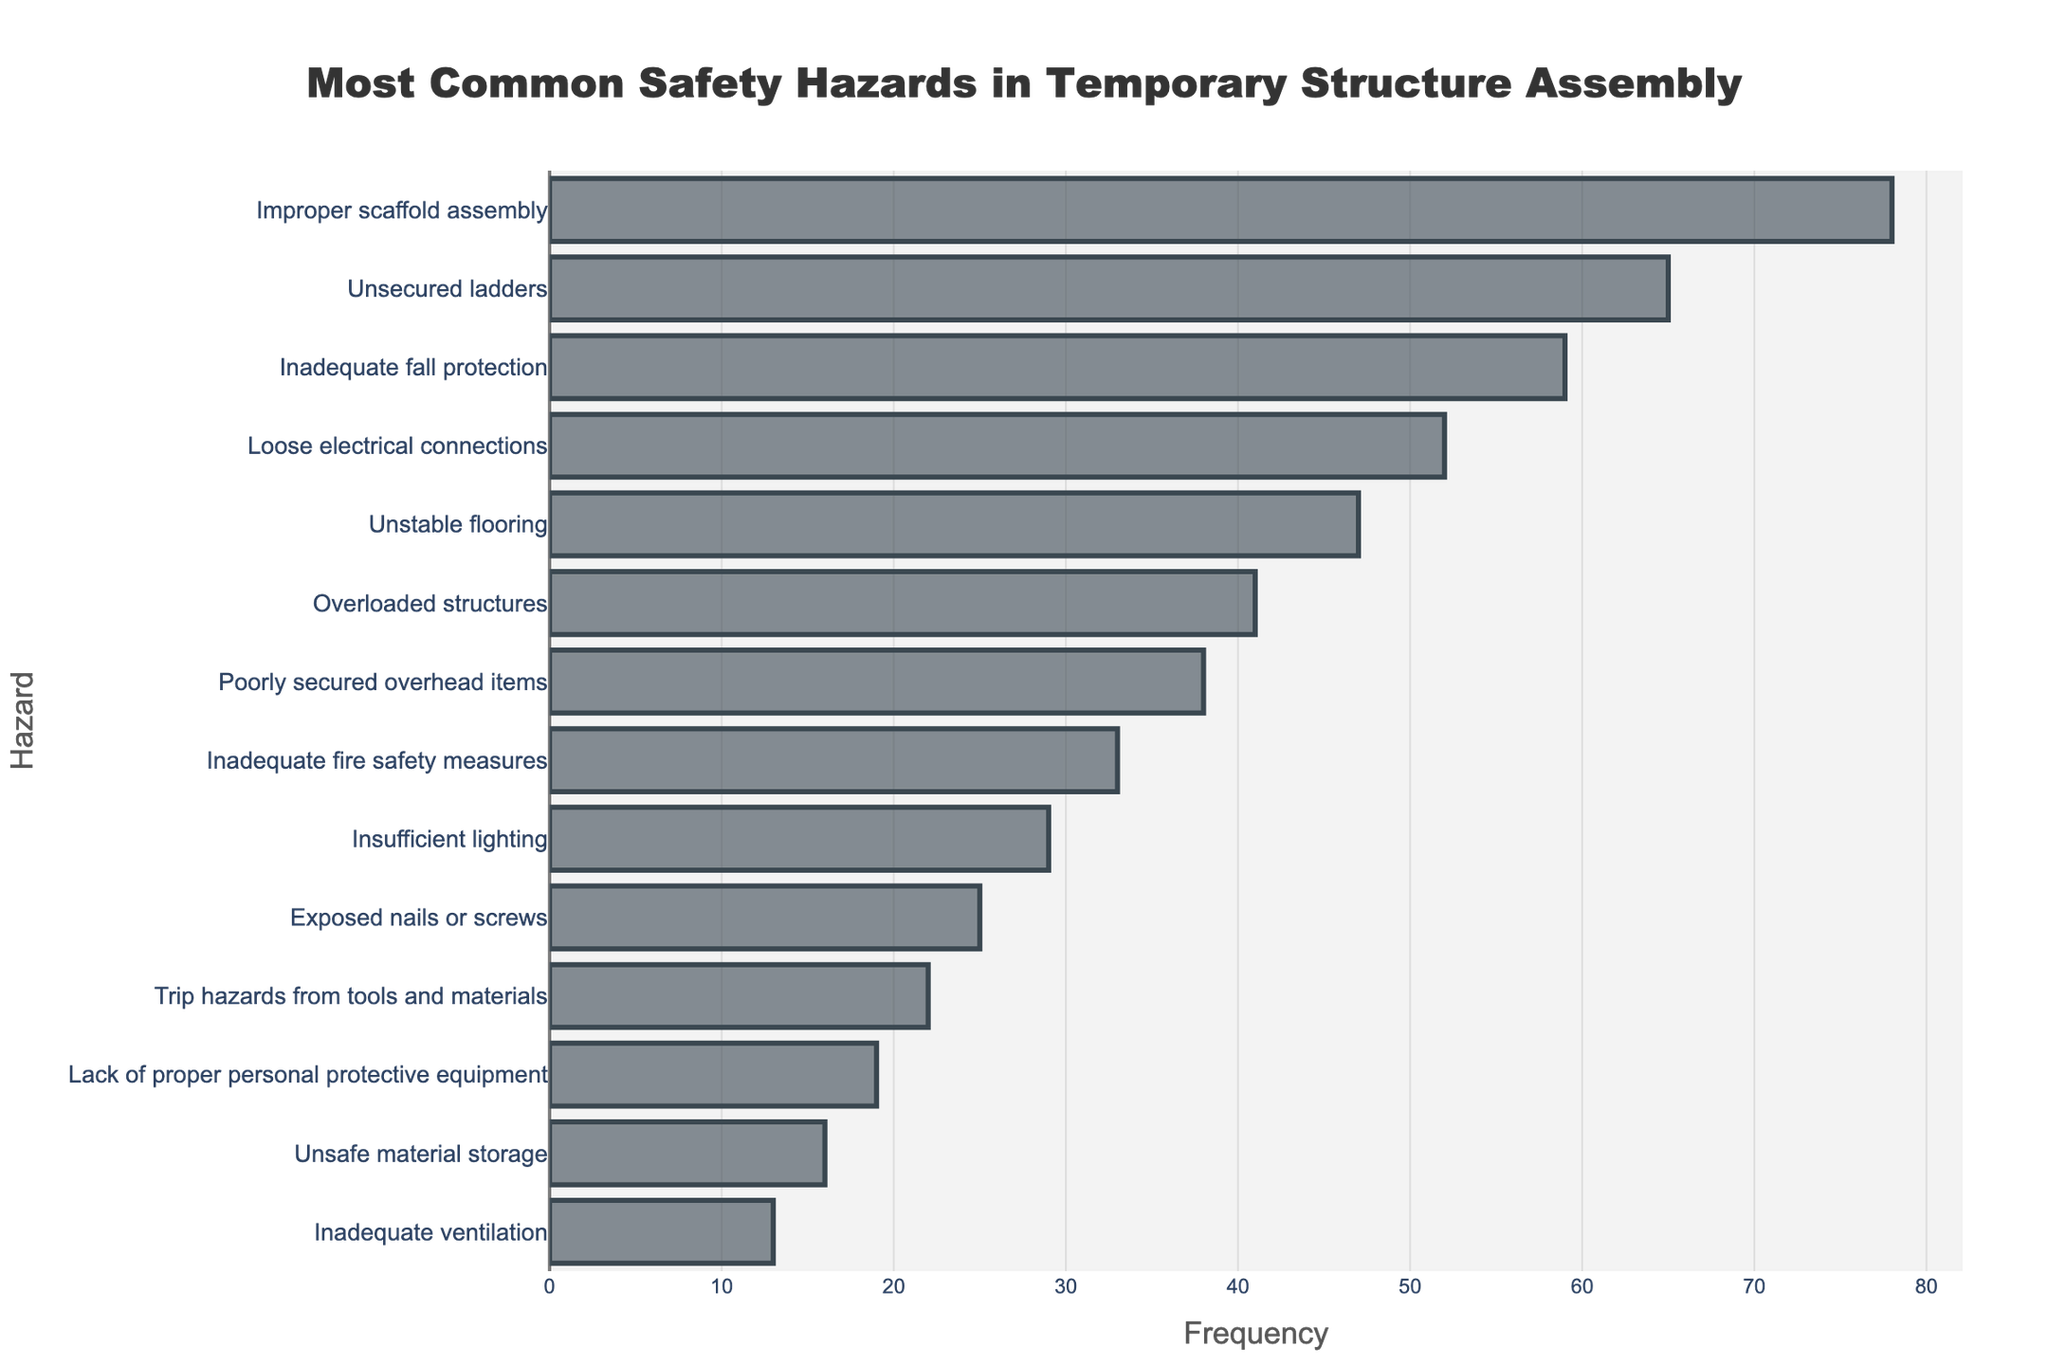What is the most common safety hazard in temporary structure assembly? The bar chart shows the frequency of each hazard, and the hazard with the longest bar is the most common. "Improper scaffold assembly" has the longest bar with a frequency of 78.
Answer: Improper scaffold assembly Which safety hazard has the lowest frequency? The bar chart lists the frequencies in descending order with the shortest bar representing the least common hazard. "Inadequate ventilation" has the shortest bar with a frequency of 13.
Answer: Inadequate ventilation How much more frequent is "Improper scaffold assembly" compared to "Unsafe material storage"? "Improper scaffold assembly" has a frequency of 78, and "Unsafe material storage" has a frequency of 16. Subtracting the latter from the former: 78 - 16 = 62.
Answer: 62 What is the average frequency of the three most common safety hazards? The three most common hazards are "Improper scaffold assembly" (78), "Unsecured ladders" (65), and "Inadequate fall protection" (59). The average is calculated as (78 + 65 + 59) / 3 = 202 / 3 ≈ 67.33.
Answer: 67.33 Are there more hazards with frequencies above or below 40? Count the hazards with frequencies above 40: 6 hazards ("Improper scaffold assembly", "Unsecured ladders", "Inadequate fall protection", "Loose electrical connections", "Unstable flooring", "Overloaded structures"). Count those below 40: 8 hazards. There are more hazards with frequencies below 40.
Answer: Below Which hazard has a frequency closest to 50? From the bar chart, "Loose electrical connections" has a frequency of 52, which is the closest to 50.
Answer: Loose electrical connections How do the frequencies of "Unstable flooring" and "Overloaded structures" compare? "Unstable flooring" has a frequency of 47, while "Overloaded structures" has a frequency of 41. Therefore, "Unstable flooring" has a higher frequency.
Answer: Unstable flooring is higher What's the combined frequency of hazards related to electrical issues? The hazards "Loose electrical connections" (52) and "Exposed nails or screws" (25) relate to electrical issues. Their combined frequency is 52 + 25 = 77.
Answer: 77 Which three hazards have frequencies directly below "Loose electrical connections"? The bar chart shows the ordered hazards. Those directly below "Loose electrical connections" (52) are "Unstable flooring" (47), "Overloaded structures" (41), and "Poorly secured overhead items" (38).
Answer: Unstable flooring, Overloaded structures, Poorly secured overhead items 